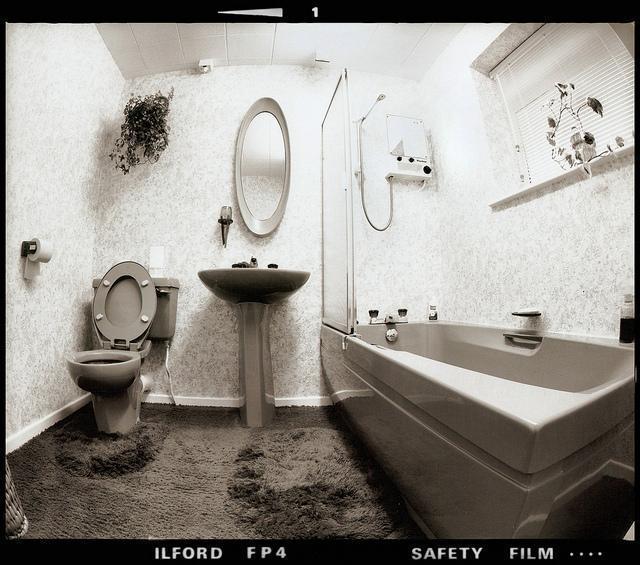How many potted plants are there?
Give a very brief answer. 2. 